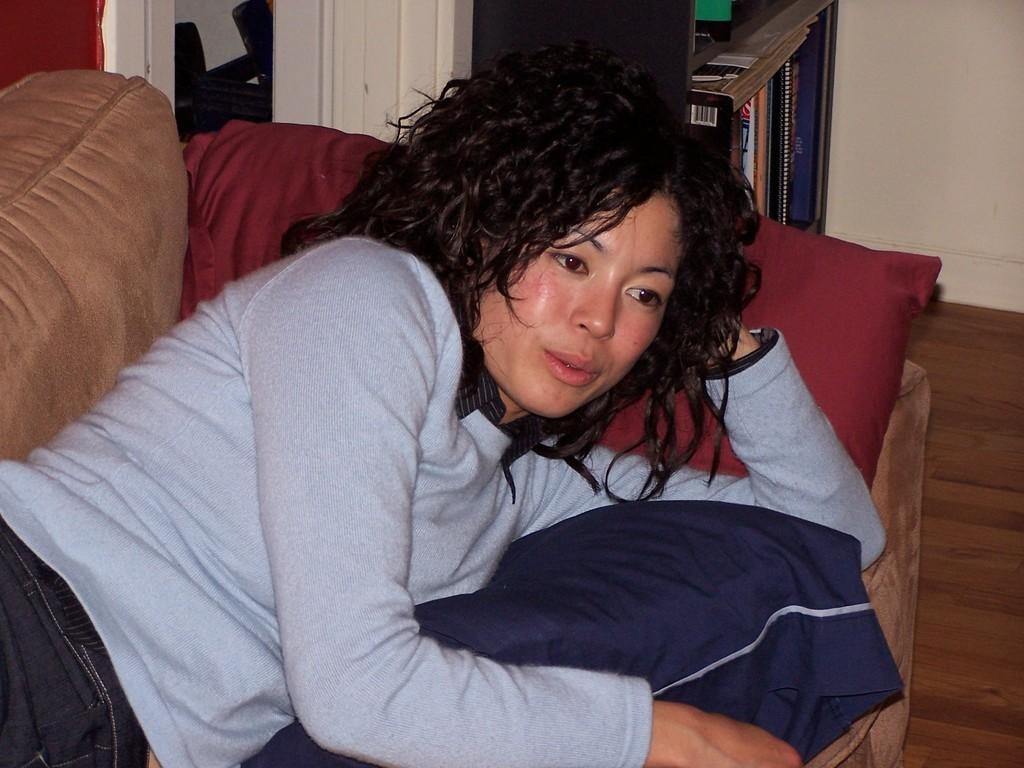What is the woman in the image doing? The woman is lying on a sofa in the image. What can be seen in the background of the image? There are books on a shelf and a wall visible in the background of the image. What type of produce is the woman holding in the image? There is no produce visible in the image; the woman is lying on a sofa and there are books on a shelf in the background. 